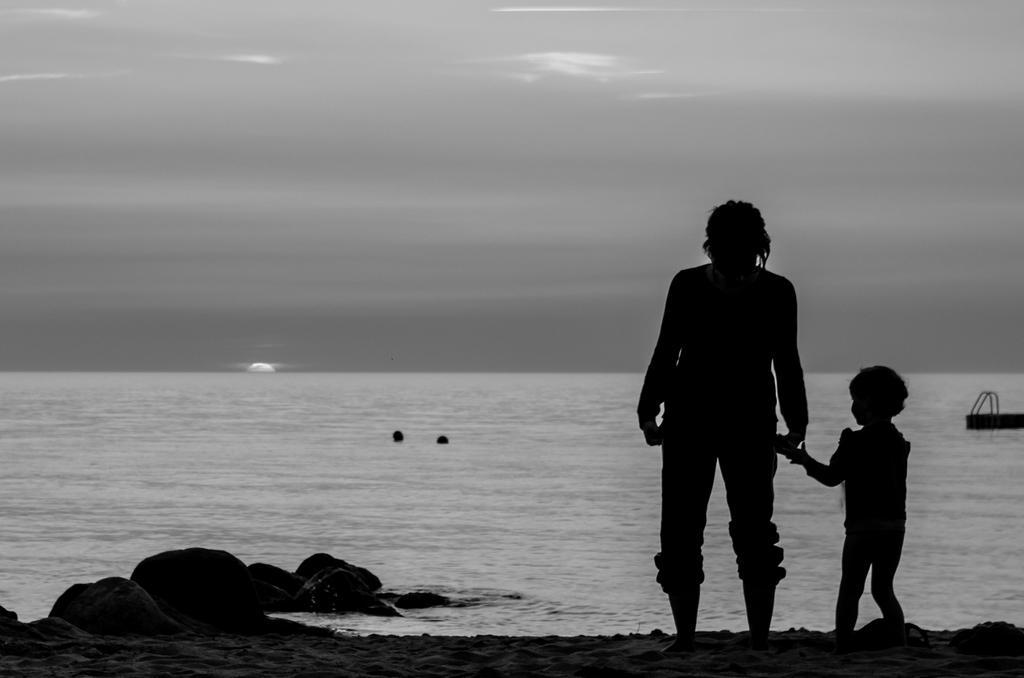Can you describe this image briefly? In the image we can see a person standing, beside the person there is a child, they are wearing clothes. This is a sandstone, water and a sky. 